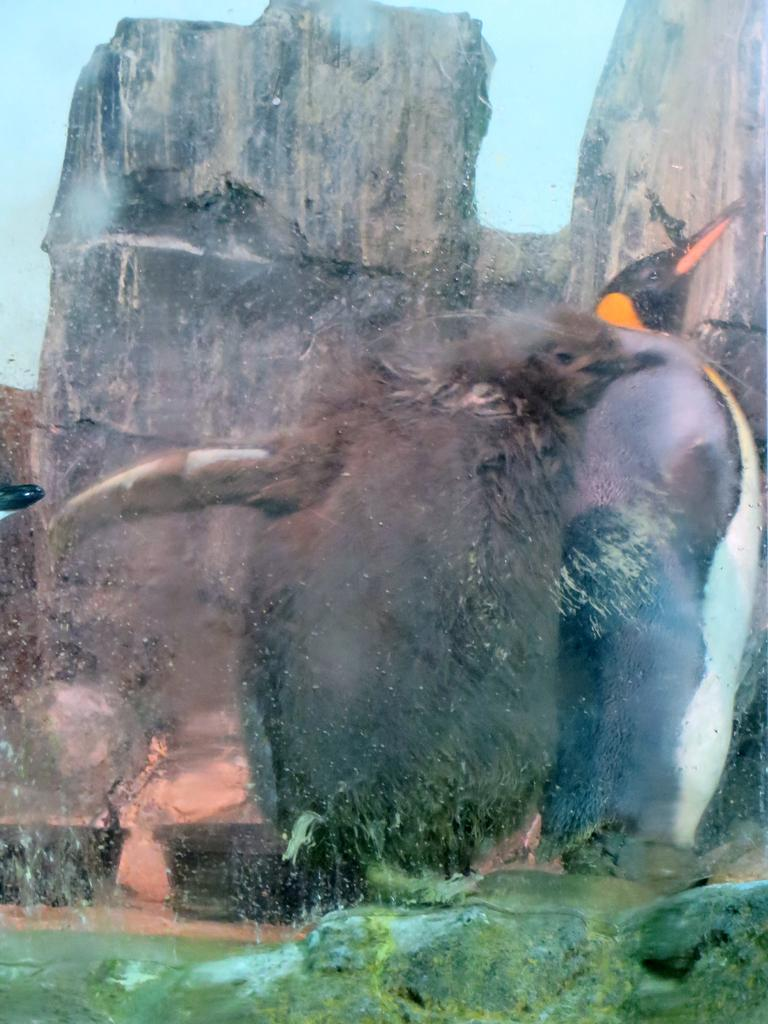What is the main subject in the middle of the image? There is a bird in the middle of the image. What can be seen at the bottom of the image? There are rocks at the bottom of the image. What is visible in the background of the image? There is a mountain in the background of the image. What type of wood is the bird using to build its nest in the image? There is no nest visible in the image, and no wood is present. 